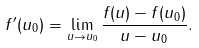Convert formula to latex. <formula><loc_0><loc_0><loc_500><loc_500>f ^ { \prime } ( u _ { 0 } ) = \lim _ { u \rightarrow u _ { 0 } } \frac { f ( u ) - f ( u _ { 0 } ) } { u - u _ { 0 } } .</formula> 